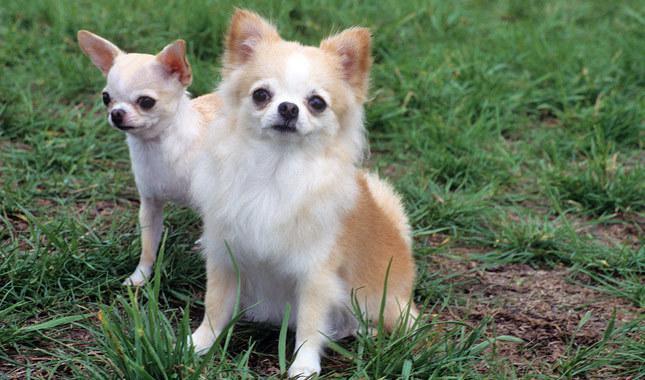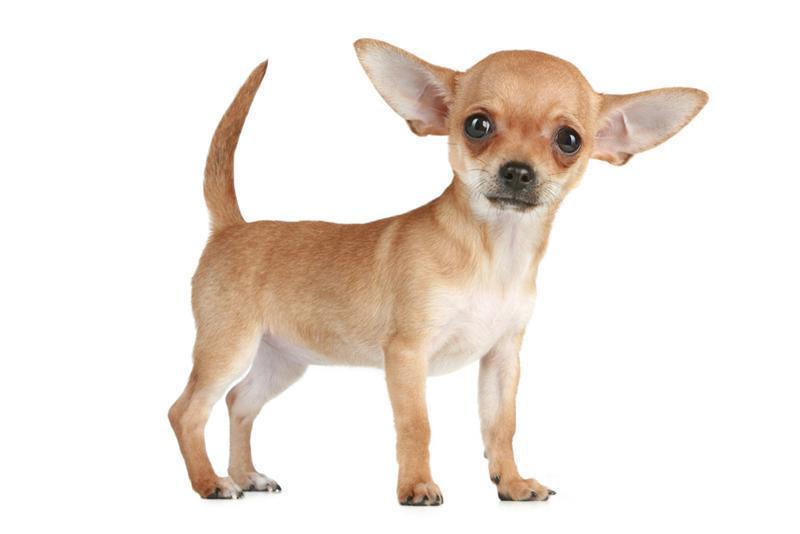The first image is the image on the left, the second image is the image on the right. Assess this claim about the two images: "Each image contains exactly one small dog.". Correct or not? Answer yes or no. No. 